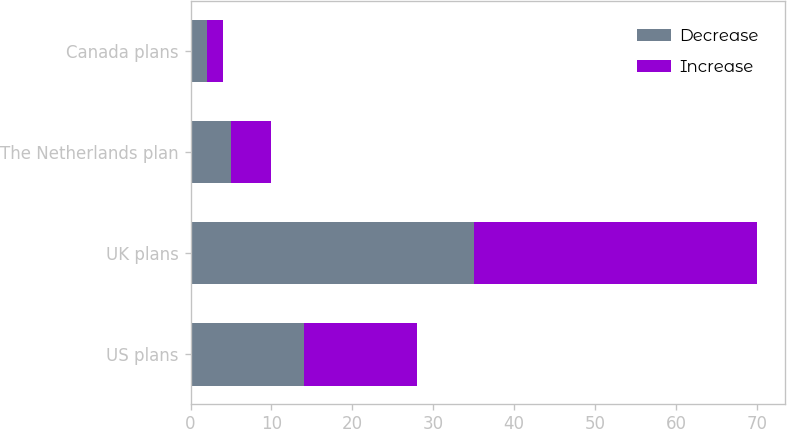Convert chart to OTSL. <chart><loc_0><loc_0><loc_500><loc_500><stacked_bar_chart><ecel><fcel>US plans<fcel>UK plans<fcel>The Netherlands plan<fcel>Canada plans<nl><fcel>Decrease<fcel>14<fcel>35<fcel>5<fcel>2<nl><fcel>Increase<fcel>14<fcel>35<fcel>5<fcel>2<nl></chart> 